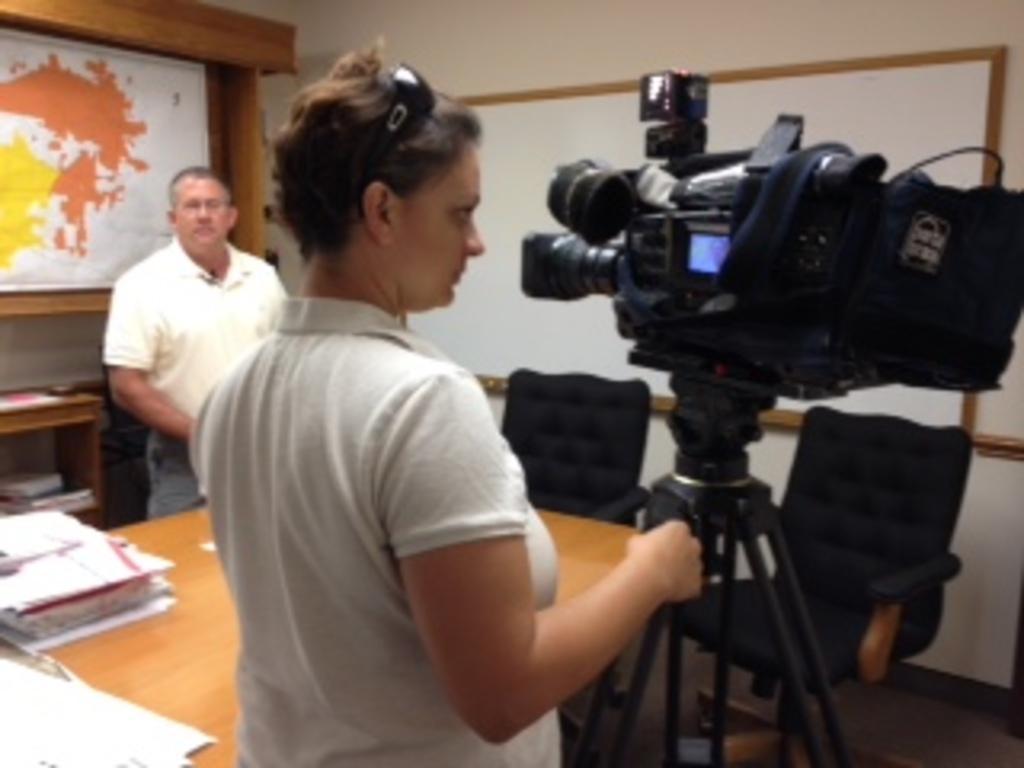How would you summarize this image in a sentence or two? This image is clicked in a room, where there is a white board on the right side. There is a video camera and stand on the right side. A woman is holding that. She is wearing white dress. That is a table in front of her and a chair and 2 chairs. On table there are files, papers. There is a man on the left side, behind him there is world map and bookshelves, books are in that bookshelves. 